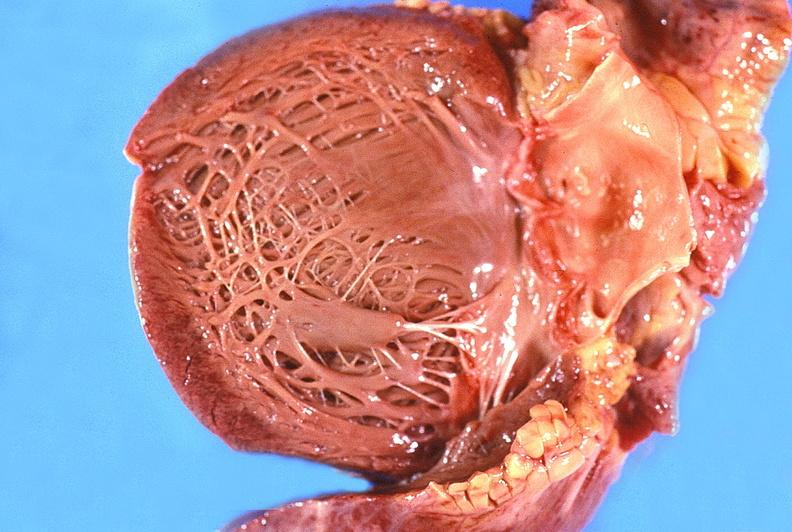s peritoneum present?
Answer the question using a single word or phrase. No 